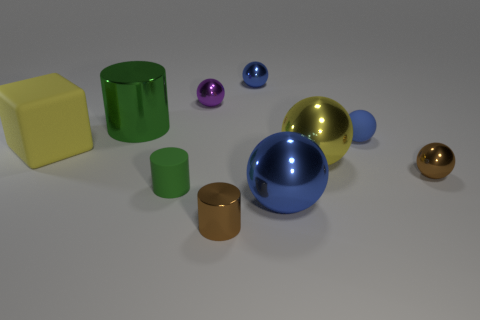Does the purple metal sphere have the same size as the yellow rubber object?
Keep it short and to the point. No. What is the material of the other cylinder that is the same color as the big cylinder?
Keep it short and to the point. Rubber. What number of other yellow matte things are the same shape as the yellow rubber thing?
Ensure brevity in your answer.  0. Are there more yellow metal spheres in front of the yellow metallic ball than small blue shiny spheres on the left side of the big block?
Give a very brief answer. No. There is a ball that is behind the purple shiny thing; is it the same color as the small matte sphere?
Keep it short and to the point. Yes. How big is the yellow cube?
Ensure brevity in your answer.  Large. What material is the green object that is the same size as the brown ball?
Keep it short and to the point. Rubber. What is the color of the large sphere that is behind the green matte thing?
Your answer should be very brief. Yellow. How many brown cubes are there?
Ensure brevity in your answer.  0. Is there a brown metal thing that is on the right side of the metallic cylinder that is in front of the tiny cylinder that is left of the purple object?
Provide a short and direct response. Yes. 